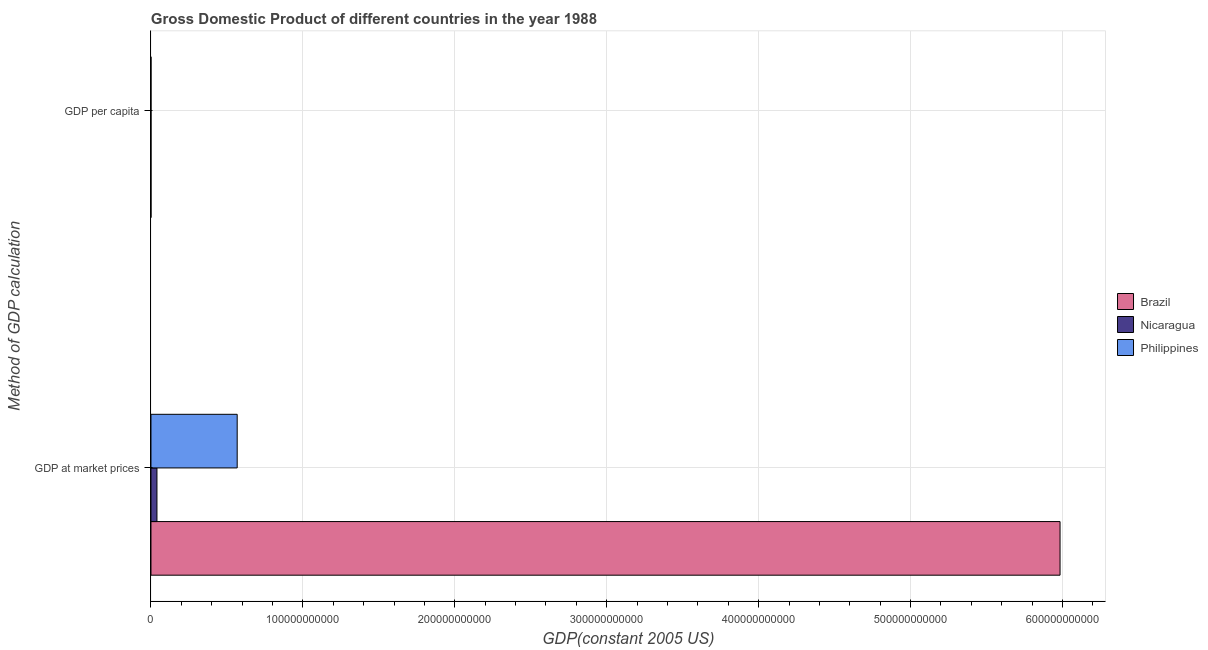How many different coloured bars are there?
Offer a very short reply. 3. How many bars are there on the 2nd tick from the top?
Your answer should be very brief. 3. How many bars are there on the 2nd tick from the bottom?
Keep it short and to the point. 3. What is the label of the 1st group of bars from the top?
Your answer should be very brief. GDP per capita. What is the gdp per capita in Brazil?
Offer a terse response. 4122.42. Across all countries, what is the maximum gdp per capita?
Keep it short and to the point. 4122.42. Across all countries, what is the minimum gdp at market prices?
Offer a terse response. 3.95e+09. In which country was the gdp per capita minimum?
Offer a terse response. Philippines. What is the total gdp at market prices in the graph?
Your response must be concise. 6.59e+11. What is the difference between the gdp at market prices in Nicaragua and that in Brazil?
Offer a very short reply. -5.94e+11. What is the difference between the gdp at market prices in Brazil and the gdp per capita in Nicaragua?
Your answer should be compact. 5.98e+11. What is the average gdp per capita per country?
Provide a succinct answer. 2027.28. What is the difference between the gdp per capita and gdp at market prices in Nicaragua?
Offer a very short reply. -3.95e+09. What is the ratio of the gdp per capita in Nicaragua to that in Brazil?
Your answer should be compact. 0.24. Is the gdp per capita in Philippines less than that in Nicaragua?
Your response must be concise. Yes. What does the 3rd bar from the top in GDP per capita represents?
Provide a succinct answer. Brazil. What does the 2nd bar from the bottom in GDP per capita represents?
Your answer should be very brief. Nicaragua. Are all the bars in the graph horizontal?
Your answer should be very brief. Yes. How many countries are there in the graph?
Keep it short and to the point. 3. What is the difference between two consecutive major ticks on the X-axis?
Provide a succinct answer. 1.00e+11. Are the values on the major ticks of X-axis written in scientific E-notation?
Give a very brief answer. No. Does the graph contain any zero values?
Your answer should be compact. No. Does the graph contain grids?
Provide a succinct answer. Yes. Where does the legend appear in the graph?
Provide a short and direct response. Center right. How are the legend labels stacked?
Make the answer very short. Vertical. What is the title of the graph?
Your response must be concise. Gross Domestic Product of different countries in the year 1988. What is the label or title of the X-axis?
Provide a succinct answer. GDP(constant 2005 US). What is the label or title of the Y-axis?
Your response must be concise. Method of GDP calculation. What is the GDP(constant 2005 US) of Brazil in GDP at market prices?
Provide a short and direct response. 5.98e+11. What is the GDP(constant 2005 US) of Nicaragua in GDP at market prices?
Your answer should be very brief. 3.95e+09. What is the GDP(constant 2005 US) of Philippines in GDP at market prices?
Ensure brevity in your answer.  5.68e+1. What is the GDP(constant 2005 US) of Brazil in GDP per capita?
Give a very brief answer. 4122.42. What is the GDP(constant 2005 US) of Nicaragua in GDP per capita?
Give a very brief answer. 995.01. What is the GDP(constant 2005 US) of Philippines in GDP per capita?
Your response must be concise. 964.42. Across all Method of GDP calculation, what is the maximum GDP(constant 2005 US) in Brazil?
Give a very brief answer. 5.98e+11. Across all Method of GDP calculation, what is the maximum GDP(constant 2005 US) in Nicaragua?
Your answer should be compact. 3.95e+09. Across all Method of GDP calculation, what is the maximum GDP(constant 2005 US) of Philippines?
Provide a short and direct response. 5.68e+1. Across all Method of GDP calculation, what is the minimum GDP(constant 2005 US) of Brazil?
Give a very brief answer. 4122.42. Across all Method of GDP calculation, what is the minimum GDP(constant 2005 US) of Nicaragua?
Offer a terse response. 995.01. Across all Method of GDP calculation, what is the minimum GDP(constant 2005 US) of Philippines?
Your response must be concise. 964.42. What is the total GDP(constant 2005 US) of Brazil in the graph?
Ensure brevity in your answer.  5.98e+11. What is the total GDP(constant 2005 US) in Nicaragua in the graph?
Your response must be concise. 3.95e+09. What is the total GDP(constant 2005 US) in Philippines in the graph?
Give a very brief answer. 5.68e+1. What is the difference between the GDP(constant 2005 US) in Brazil in GDP at market prices and that in GDP per capita?
Provide a short and direct response. 5.98e+11. What is the difference between the GDP(constant 2005 US) in Nicaragua in GDP at market prices and that in GDP per capita?
Your response must be concise. 3.95e+09. What is the difference between the GDP(constant 2005 US) in Philippines in GDP at market prices and that in GDP per capita?
Offer a terse response. 5.68e+1. What is the difference between the GDP(constant 2005 US) in Brazil in GDP at market prices and the GDP(constant 2005 US) in Nicaragua in GDP per capita?
Give a very brief answer. 5.98e+11. What is the difference between the GDP(constant 2005 US) of Brazil in GDP at market prices and the GDP(constant 2005 US) of Philippines in GDP per capita?
Ensure brevity in your answer.  5.98e+11. What is the difference between the GDP(constant 2005 US) in Nicaragua in GDP at market prices and the GDP(constant 2005 US) in Philippines in GDP per capita?
Keep it short and to the point. 3.95e+09. What is the average GDP(constant 2005 US) in Brazil per Method of GDP calculation?
Ensure brevity in your answer.  2.99e+11. What is the average GDP(constant 2005 US) in Nicaragua per Method of GDP calculation?
Offer a terse response. 1.97e+09. What is the average GDP(constant 2005 US) in Philippines per Method of GDP calculation?
Your answer should be compact. 2.84e+1. What is the difference between the GDP(constant 2005 US) of Brazil and GDP(constant 2005 US) of Nicaragua in GDP at market prices?
Give a very brief answer. 5.94e+11. What is the difference between the GDP(constant 2005 US) of Brazil and GDP(constant 2005 US) of Philippines in GDP at market prices?
Your response must be concise. 5.42e+11. What is the difference between the GDP(constant 2005 US) in Nicaragua and GDP(constant 2005 US) in Philippines in GDP at market prices?
Give a very brief answer. -5.28e+1. What is the difference between the GDP(constant 2005 US) of Brazil and GDP(constant 2005 US) of Nicaragua in GDP per capita?
Your response must be concise. 3127.41. What is the difference between the GDP(constant 2005 US) in Brazil and GDP(constant 2005 US) in Philippines in GDP per capita?
Offer a very short reply. 3157.99. What is the difference between the GDP(constant 2005 US) of Nicaragua and GDP(constant 2005 US) of Philippines in GDP per capita?
Your answer should be very brief. 30.58. What is the ratio of the GDP(constant 2005 US) in Brazil in GDP at market prices to that in GDP per capita?
Make the answer very short. 1.45e+08. What is the ratio of the GDP(constant 2005 US) in Nicaragua in GDP at market prices to that in GDP per capita?
Offer a very short reply. 3.97e+06. What is the ratio of the GDP(constant 2005 US) in Philippines in GDP at market prices to that in GDP per capita?
Make the answer very short. 5.88e+07. What is the difference between the highest and the second highest GDP(constant 2005 US) of Brazil?
Offer a very short reply. 5.98e+11. What is the difference between the highest and the second highest GDP(constant 2005 US) in Nicaragua?
Make the answer very short. 3.95e+09. What is the difference between the highest and the second highest GDP(constant 2005 US) of Philippines?
Make the answer very short. 5.68e+1. What is the difference between the highest and the lowest GDP(constant 2005 US) of Brazil?
Keep it short and to the point. 5.98e+11. What is the difference between the highest and the lowest GDP(constant 2005 US) in Nicaragua?
Make the answer very short. 3.95e+09. What is the difference between the highest and the lowest GDP(constant 2005 US) in Philippines?
Ensure brevity in your answer.  5.68e+1. 